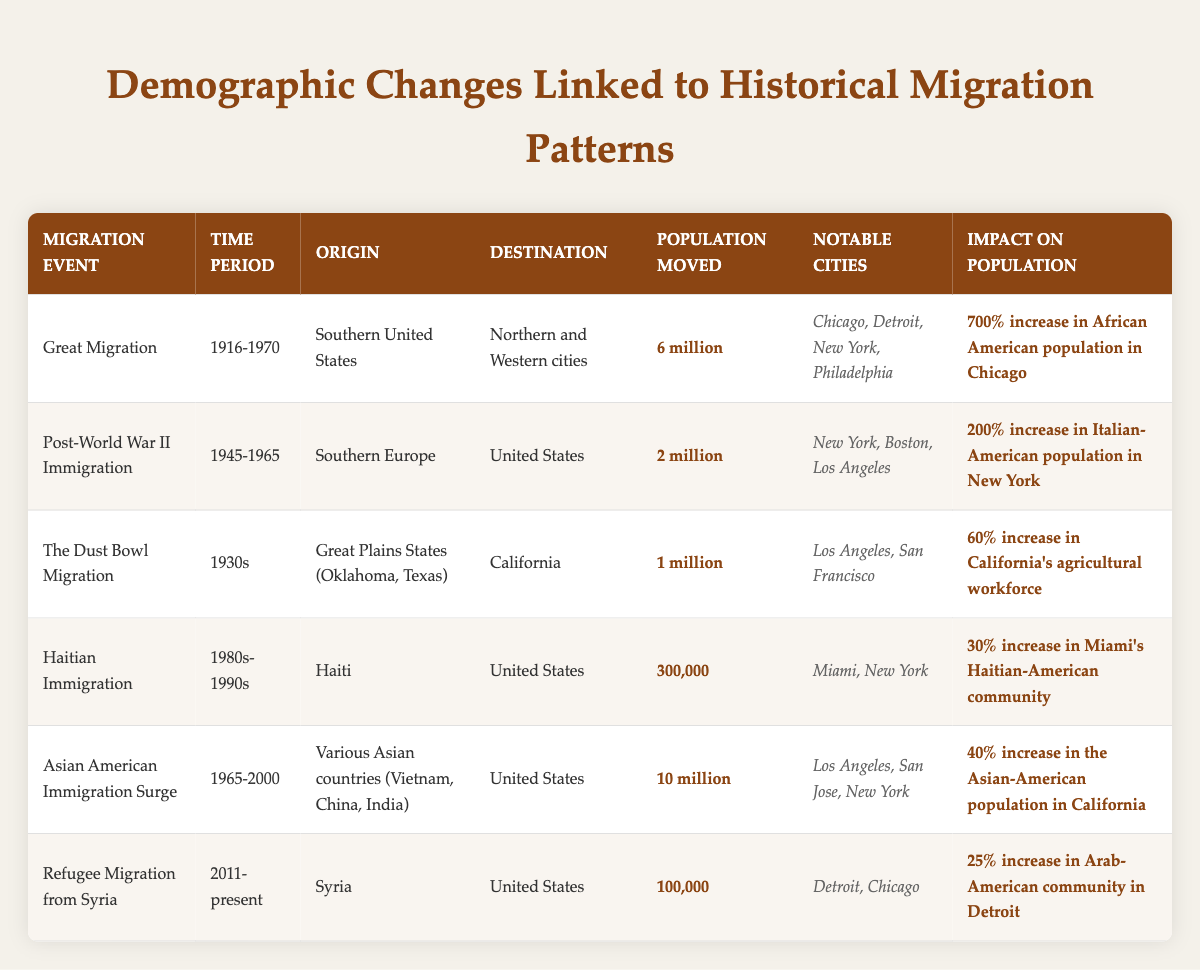What was the population moved during the Great Migration? The table states that the population moved during the Great Migration is **6 million**.
Answer: 6 million Which migration event led to a 200% increase in the Italian-American population in New York? The table indicates that the Post-World War II Immigration event resulted in a **200% increase** in the Italian-American population in New York.
Answer: Post-World War II Immigration How many notable cities are listed for the Dust Bowl Migration? The table provides two notable cities for the Dust Bowl Migration: Los Angeles and San Francisco, making a total of **2 notable cities**.
Answer: 2 What was the impact on California's agricultural workforce due to the Dust Bowl Migration? The table specifies a **60% increase** in California's agricultural workforce resulting from the Dust Bowl Migration.
Answer: 60% increase Determine the total population moved from the Asian American Immigration Surge and the Great Migration combined. Combine the populations: **10 million** (Asian American Immigration Surge) + **6 million** (Great Migration) = **16 million**.
Answer: 16 million True or False: The refugee migration from Syria led to a 25% increase in the Arab-American community in New York. The table shows that the impact was a **25% increase** in the Arab-American community in Detroit, not New York, thus the statement is false.
Answer: False Which migration event had the highest population moved? Comparing the values, the Asian American Immigration Surge, with **10 million** moved, has the highest population moved among the events listed in the table.
Answer: Asian American Immigration Surge What is the percentage increase in Miami's Haitian-American community due to Haitian Immigration? The table notes a **30% increase** in Miami's Haitian-American community due to Haitian Immigration during the 1980s-1990s.
Answer: 30% increase If we compare the populations moved from the Great Migration and Haitian Immigration, what is the difference? The difference is: **6 million** (Great Migration) - **300,000** (Haitian Immigration) = **5.7 million**.
Answer: 5.7 million Identify the time period with the lowest population moved. The table lists Haitian Immigration as having the lowest population moved at **300,000** during the period of 1980s-1990s.
Answer: 1980s-1990s 